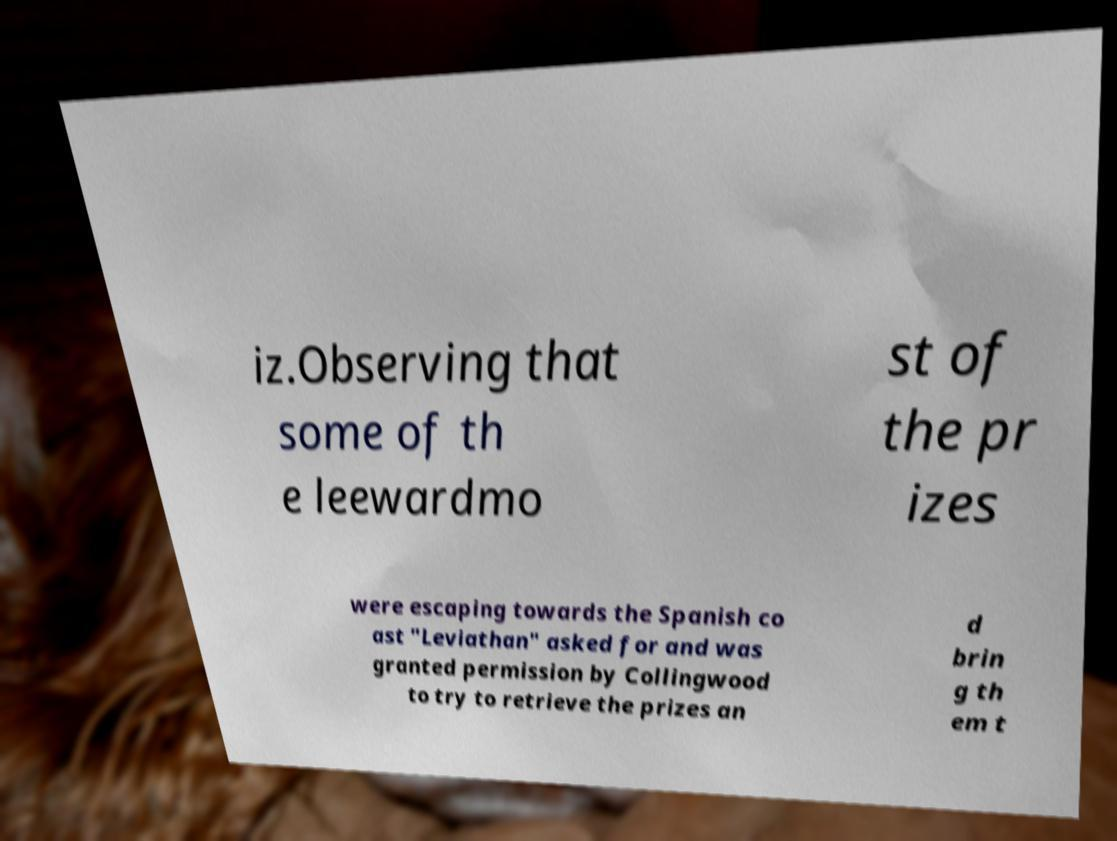Please read and relay the text visible in this image. What does it say? iz.Observing that some of th e leewardmo st of the pr izes were escaping towards the Spanish co ast "Leviathan" asked for and was granted permission by Collingwood to try to retrieve the prizes an d brin g th em t 